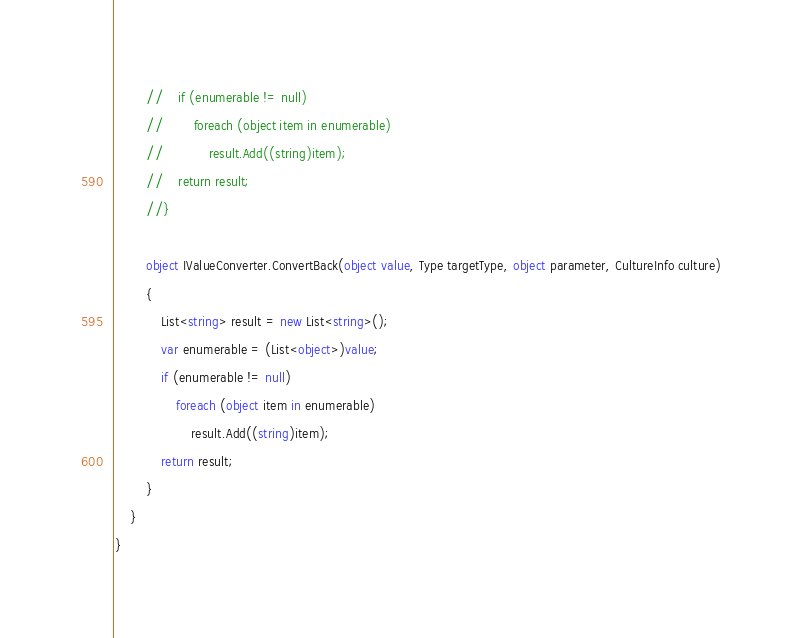Convert code to text. <code><loc_0><loc_0><loc_500><loc_500><_C#_>        //    if (enumerable != null)
        //        foreach (object item in enumerable)
        //            result.Add((string)item);
        //    return result;
        //}

        object IValueConverter.ConvertBack(object value, Type targetType, object parameter, CultureInfo culture)
        {
            List<string> result = new List<string>();
            var enumerable = (List<object>)value;
            if (enumerable != null)
                foreach (object item in enumerable)
                    result.Add((string)item);
            return result;
        }
    }
}
</code> 